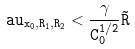<formula> <loc_0><loc_0><loc_500><loc_500>\tt a u _ { x _ { 0 } , R _ { 1 } , R _ { 2 } } < \frac { \gamma } { C _ { 0 } ^ { 1 / 2 } } \tilde { R } \,</formula> 